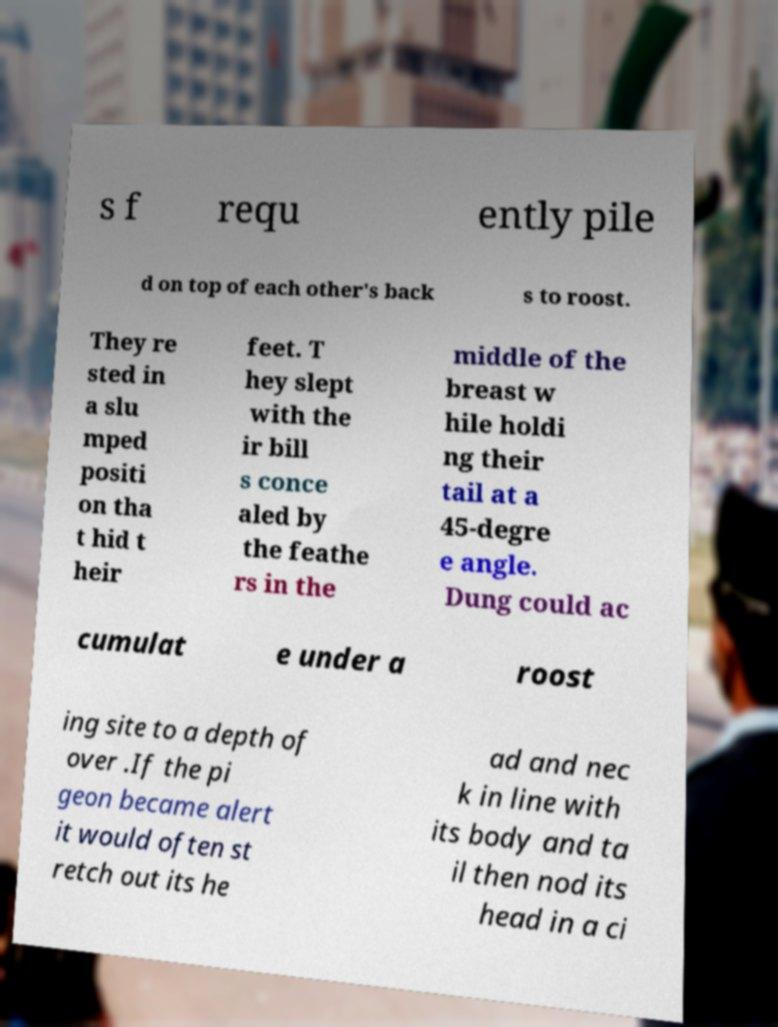Could you assist in decoding the text presented in this image and type it out clearly? s f requ ently pile d on top of each other's back s to roost. They re sted in a slu mped positi on tha t hid t heir feet. T hey slept with the ir bill s conce aled by the feathe rs in the middle of the breast w hile holdi ng their tail at a 45-degre e angle. Dung could ac cumulat e under a roost ing site to a depth of over .If the pi geon became alert it would often st retch out its he ad and nec k in line with its body and ta il then nod its head in a ci 